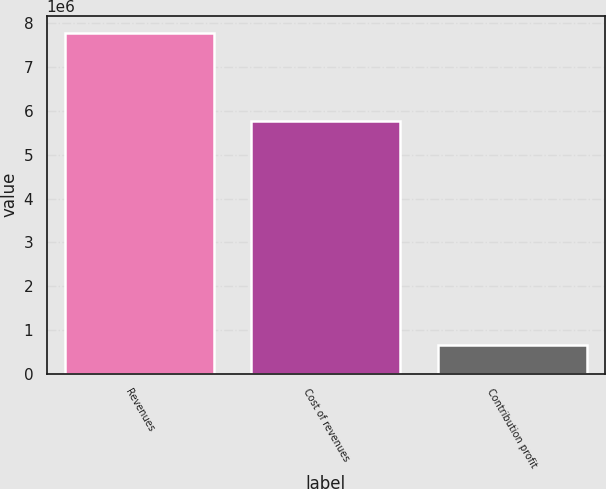<chart> <loc_0><loc_0><loc_500><loc_500><bar_chart><fcel>Revenues<fcel>Cost of revenues<fcel>Contribution profit<nl><fcel>7.7821e+06<fcel>5.77605e+06<fcel>661940<nl></chart> 